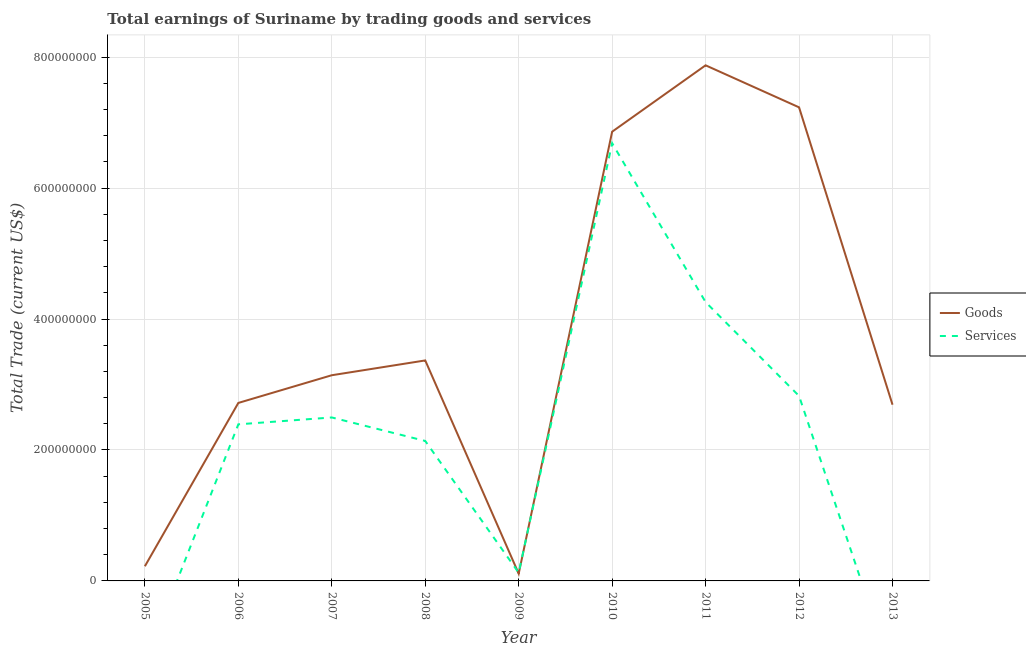How many different coloured lines are there?
Ensure brevity in your answer.  2. What is the amount earned by trading goods in 2007?
Ensure brevity in your answer.  3.14e+08. Across all years, what is the maximum amount earned by trading services?
Make the answer very short. 6.69e+08. In which year was the amount earned by trading services maximum?
Give a very brief answer. 2010. What is the total amount earned by trading services in the graph?
Make the answer very short. 2.09e+09. What is the difference between the amount earned by trading services in 2009 and that in 2011?
Make the answer very short. -4.13e+08. What is the difference between the amount earned by trading services in 2007 and the amount earned by trading goods in 2011?
Offer a terse response. -5.38e+08. What is the average amount earned by trading goods per year?
Offer a very short reply. 3.80e+08. In the year 2007, what is the difference between the amount earned by trading services and amount earned by trading goods?
Offer a very short reply. -6.45e+07. What is the ratio of the amount earned by trading services in 2010 to that in 2011?
Keep it short and to the point. 1.57. Is the difference between the amount earned by trading services in 2006 and 2008 greater than the difference between the amount earned by trading goods in 2006 and 2008?
Give a very brief answer. Yes. What is the difference between the highest and the second highest amount earned by trading services?
Your response must be concise. 2.43e+08. What is the difference between the highest and the lowest amount earned by trading goods?
Provide a succinct answer. 7.77e+08. Is the sum of the amount earned by trading goods in 2007 and 2010 greater than the maximum amount earned by trading services across all years?
Ensure brevity in your answer.  Yes. How many lines are there?
Keep it short and to the point. 2. Does the graph contain any zero values?
Ensure brevity in your answer.  Yes. How many legend labels are there?
Your response must be concise. 2. How are the legend labels stacked?
Offer a terse response. Vertical. What is the title of the graph?
Your response must be concise. Total earnings of Suriname by trading goods and services. Does "IMF concessional" appear as one of the legend labels in the graph?
Give a very brief answer. No. What is the label or title of the X-axis?
Your response must be concise. Year. What is the label or title of the Y-axis?
Provide a succinct answer. Total Trade (current US$). What is the Total Trade (current US$) in Goods in 2005?
Make the answer very short. 2.24e+07. What is the Total Trade (current US$) of Goods in 2006?
Give a very brief answer. 2.72e+08. What is the Total Trade (current US$) in Services in 2006?
Offer a terse response. 2.39e+08. What is the Total Trade (current US$) in Goods in 2007?
Provide a short and direct response. 3.14e+08. What is the Total Trade (current US$) of Services in 2007?
Make the answer very short. 2.50e+08. What is the Total Trade (current US$) in Goods in 2008?
Keep it short and to the point. 3.37e+08. What is the Total Trade (current US$) in Services in 2008?
Ensure brevity in your answer.  2.14e+08. What is the Total Trade (current US$) of Goods in 2009?
Offer a very short reply. 1.11e+07. What is the Total Trade (current US$) in Services in 2009?
Offer a terse response. 1.25e+07. What is the Total Trade (current US$) of Goods in 2010?
Provide a short and direct response. 6.86e+08. What is the Total Trade (current US$) in Services in 2010?
Provide a succinct answer. 6.69e+08. What is the Total Trade (current US$) in Goods in 2011?
Your answer should be compact. 7.88e+08. What is the Total Trade (current US$) in Services in 2011?
Ensure brevity in your answer.  4.26e+08. What is the Total Trade (current US$) of Goods in 2012?
Give a very brief answer. 7.23e+08. What is the Total Trade (current US$) in Services in 2012?
Offer a terse response. 2.83e+08. What is the Total Trade (current US$) in Goods in 2013?
Your answer should be compact. 2.69e+08. Across all years, what is the maximum Total Trade (current US$) in Goods?
Ensure brevity in your answer.  7.88e+08. Across all years, what is the maximum Total Trade (current US$) of Services?
Provide a succinct answer. 6.69e+08. Across all years, what is the minimum Total Trade (current US$) of Goods?
Provide a short and direct response. 1.11e+07. What is the total Total Trade (current US$) in Goods in the graph?
Your answer should be very brief. 3.42e+09. What is the total Total Trade (current US$) of Services in the graph?
Offer a very short reply. 2.09e+09. What is the difference between the Total Trade (current US$) of Goods in 2005 and that in 2006?
Your answer should be very brief. -2.50e+08. What is the difference between the Total Trade (current US$) in Goods in 2005 and that in 2007?
Offer a very short reply. -2.92e+08. What is the difference between the Total Trade (current US$) of Goods in 2005 and that in 2008?
Offer a terse response. -3.14e+08. What is the difference between the Total Trade (current US$) in Goods in 2005 and that in 2009?
Your answer should be compact. 1.13e+07. What is the difference between the Total Trade (current US$) in Goods in 2005 and that in 2010?
Provide a succinct answer. -6.64e+08. What is the difference between the Total Trade (current US$) of Goods in 2005 and that in 2011?
Provide a succinct answer. -7.65e+08. What is the difference between the Total Trade (current US$) of Goods in 2005 and that in 2012?
Your answer should be compact. -7.01e+08. What is the difference between the Total Trade (current US$) of Goods in 2005 and that in 2013?
Ensure brevity in your answer.  -2.47e+08. What is the difference between the Total Trade (current US$) in Goods in 2006 and that in 2007?
Make the answer very short. -4.23e+07. What is the difference between the Total Trade (current US$) in Services in 2006 and that in 2007?
Your answer should be compact. -1.05e+07. What is the difference between the Total Trade (current US$) in Goods in 2006 and that in 2008?
Offer a very short reply. -6.49e+07. What is the difference between the Total Trade (current US$) in Services in 2006 and that in 2008?
Ensure brevity in your answer.  2.54e+07. What is the difference between the Total Trade (current US$) in Goods in 2006 and that in 2009?
Your response must be concise. 2.61e+08. What is the difference between the Total Trade (current US$) in Services in 2006 and that in 2009?
Give a very brief answer. 2.27e+08. What is the difference between the Total Trade (current US$) of Goods in 2006 and that in 2010?
Make the answer very short. -4.14e+08. What is the difference between the Total Trade (current US$) of Services in 2006 and that in 2010?
Ensure brevity in your answer.  -4.29e+08. What is the difference between the Total Trade (current US$) in Goods in 2006 and that in 2011?
Provide a short and direct response. -5.16e+08. What is the difference between the Total Trade (current US$) in Services in 2006 and that in 2011?
Offer a very short reply. -1.87e+08. What is the difference between the Total Trade (current US$) of Goods in 2006 and that in 2012?
Provide a succinct answer. -4.52e+08. What is the difference between the Total Trade (current US$) of Services in 2006 and that in 2012?
Provide a short and direct response. -4.34e+07. What is the difference between the Total Trade (current US$) of Goods in 2006 and that in 2013?
Ensure brevity in your answer.  2.72e+06. What is the difference between the Total Trade (current US$) in Goods in 2007 and that in 2008?
Offer a terse response. -2.26e+07. What is the difference between the Total Trade (current US$) of Services in 2007 and that in 2008?
Keep it short and to the point. 3.59e+07. What is the difference between the Total Trade (current US$) in Goods in 2007 and that in 2009?
Offer a very short reply. 3.03e+08. What is the difference between the Total Trade (current US$) in Services in 2007 and that in 2009?
Your answer should be compact. 2.37e+08. What is the difference between the Total Trade (current US$) in Goods in 2007 and that in 2010?
Offer a very short reply. -3.72e+08. What is the difference between the Total Trade (current US$) of Services in 2007 and that in 2010?
Make the answer very short. -4.19e+08. What is the difference between the Total Trade (current US$) in Goods in 2007 and that in 2011?
Your answer should be very brief. -4.73e+08. What is the difference between the Total Trade (current US$) of Services in 2007 and that in 2011?
Keep it short and to the point. -1.76e+08. What is the difference between the Total Trade (current US$) of Goods in 2007 and that in 2012?
Keep it short and to the point. -4.09e+08. What is the difference between the Total Trade (current US$) of Services in 2007 and that in 2012?
Give a very brief answer. -3.29e+07. What is the difference between the Total Trade (current US$) in Goods in 2007 and that in 2013?
Provide a succinct answer. 4.50e+07. What is the difference between the Total Trade (current US$) of Goods in 2008 and that in 2009?
Your answer should be very brief. 3.26e+08. What is the difference between the Total Trade (current US$) of Services in 2008 and that in 2009?
Provide a short and direct response. 2.01e+08. What is the difference between the Total Trade (current US$) in Goods in 2008 and that in 2010?
Your response must be concise. -3.49e+08. What is the difference between the Total Trade (current US$) of Services in 2008 and that in 2010?
Offer a terse response. -4.55e+08. What is the difference between the Total Trade (current US$) in Goods in 2008 and that in 2011?
Give a very brief answer. -4.51e+08. What is the difference between the Total Trade (current US$) of Services in 2008 and that in 2011?
Offer a terse response. -2.12e+08. What is the difference between the Total Trade (current US$) of Goods in 2008 and that in 2012?
Offer a very short reply. -3.87e+08. What is the difference between the Total Trade (current US$) in Services in 2008 and that in 2012?
Ensure brevity in your answer.  -6.88e+07. What is the difference between the Total Trade (current US$) in Goods in 2008 and that in 2013?
Give a very brief answer. 6.76e+07. What is the difference between the Total Trade (current US$) in Goods in 2009 and that in 2010?
Provide a succinct answer. -6.75e+08. What is the difference between the Total Trade (current US$) in Services in 2009 and that in 2010?
Provide a short and direct response. -6.56e+08. What is the difference between the Total Trade (current US$) in Goods in 2009 and that in 2011?
Keep it short and to the point. -7.77e+08. What is the difference between the Total Trade (current US$) in Services in 2009 and that in 2011?
Your answer should be very brief. -4.13e+08. What is the difference between the Total Trade (current US$) of Goods in 2009 and that in 2012?
Ensure brevity in your answer.  -7.12e+08. What is the difference between the Total Trade (current US$) in Services in 2009 and that in 2012?
Ensure brevity in your answer.  -2.70e+08. What is the difference between the Total Trade (current US$) in Goods in 2009 and that in 2013?
Offer a very short reply. -2.58e+08. What is the difference between the Total Trade (current US$) of Goods in 2010 and that in 2011?
Your answer should be very brief. -1.01e+08. What is the difference between the Total Trade (current US$) of Services in 2010 and that in 2011?
Your answer should be very brief. 2.43e+08. What is the difference between the Total Trade (current US$) of Goods in 2010 and that in 2012?
Provide a succinct answer. -3.72e+07. What is the difference between the Total Trade (current US$) of Services in 2010 and that in 2012?
Give a very brief answer. 3.86e+08. What is the difference between the Total Trade (current US$) in Goods in 2010 and that in 2013?
Make the answer very short. 4.17e+08. What is the difference between the Total Trade (current US$) of Goods in 2011 and that in 2012?
Provide a short and direct response. 6.42e+07. What is the difference between the Total Trade (current US$) in Services in 2011 and that in 2012?
Offer a very short reply. 1.43e+08. What is the difference between the Total Trade (current US$) of Goods in 2011 and that in 2013?
Your answer should be very brief. 5.18e+08. What is the difference between the Total Trade (current US$) of Goods in 2012 and that in 2013?
Give a very brief answer. 4.54e+08. What is the difference between the Total Trade (current US$) of Goods in 2005 and the Total Trade (current US$) of Services in 2006?
Your answer should be very brief. -2.17e+08. What is the difference between the Total Trade (current US$) of Goods in 2005 and the Total Trade (current US$) of Services in 2007?
Make the answer very short. -2.27e+08. What is the difference between the Total Trade (current US$) in Goods in 2005 and the Total Trade (current US$) in Services in 2008?
Your answer should be very brief. -1.91e+08. What is the difference between the Total Trade (current US$) in Goods in 2005 and the Total Trade (current US$) in Services in 2009?
Give a very brief answer. 9.90e+06. What is the difference between the Total Trade (current US$) of Goods in 2005 and the Total Trade (current US$) of Services in 2010?
Ensure brevity in your answer.  -6.46e+08. What is the difference between the Total Trade (current US$) in Goods in 2005 and the Total Trade (current US$) in Services in 2011?
Make the answer very short. -4.04e+08. What is the difference between the Total Trade (current US$) of Goods in 2005 and the Total Trade (current US$) of Services in 2012?
Offer a very short reply. -2.60e+08. What is the difference between the Total Trade (current US$) of Goods in 2006 and the Total Trade (current US$) of Services in 2007?
Provide a short and direct response. 2.22e+07. What is the difference between the Total Trade (current US$) in Goods in 2006 and the Total Trade (current US$) in Services in 2008?
Offer a very short reply. 5.81e+07. What is the difference between the Total Trade (current US$) in Goods in 2006 and the Total Trade (current US$) in Services in 2009?
Offer a very short reply. 2.59e+08. What is the difference between the Total Trade (current US$) of Goods in 2006 and the Total Trade (current US$) of Services in 2010?
Give a very brief answer. -3.97e+08. What is the difference between the Total Trade (current US$) of Goods in 2006 and the Total Trade (current US$) of Services in 2011?
Your answer should be compact. -1.54e+08. What is the difference between the Total Trade (current US$) of Goods in 2006 and the Total Trade (current US$) of Services in 2012?
Make the answer very short. -1.07e+07. What is the difference between the Total Trade (current US$) of Goods in 2007 and the Total Trade (current US$) of Services in 2008?
Offer a very short reply. 1.00e+08. What is the difference between the Total Trade (current US$) in Goods in 2007 and the Total Trade (current US$) in Services in 2009?
Your answer should be very brief. 3.02e+08. What is the difference between the Total Trade (current US$) of Goods in 2007 and the Total Trade (current US$) of Services in 2010?
Offer a very short reply. -3.54e+08. What is the difference between the Total Trade (current US$) in Goods in 2007 and the Total Trade (current US$) in Services in 2011?
Keep it short and to the point. -1.12e+08. What is the difference between the Total Trade (current US$) in Goods in 2007 and the Total Trade (current US$) in Services in 2012?
Provide a short and direct response. 3.16e+07. What is the difference between the Total Trade (current US$) in Goods in 2008 and the Total Trade (current US$) in Services in 2009?
Offer a terse response. 3.24e+08. What is the difference between the Total Trade (current US$) of Goods in 2008 and the Total Trade (current US$) of Services in 2010?
Offer a terse response. -3.32e+08. What is the difference between the Total Trade (current US$) in Goods in 2008 and the Total Trade (current US$) in Services in 2011?
Keep it short and to the point. -8.91e+07. What is the difference between the Total Trade (current US$) of Goods in 2008 and the Total Trade (current US$) of Services in 2012?
Your response must be concise. 5.42e+07. What is the difference between the Total Trade (current US$) in Goods in 2009 and the Total Trade (current US$) in Services in 2010?
Your response must be concise. -6.58e+08. What is the difference between the Total Trade (current US$) of Goods in 2009 and the Total Trade (current US$) of Services in 2011?
Your response must be concise. -4.15e+08. What is the difference between the Total Trade (current US$) in Goods in 2009 and the Total Trade (current US$) in Services in 2012?
Offer a very short reply. -2.71e+08. What is the difference between the Total Trade (current US$) in Goods in 2010 and the Total Trade (current US$) in Services in 2011?
Provide a short and direct response. 2.60e+08. What is the difference between the Total Trade (current US$) in Goods in 2010 and the Total Trade (current US$) in Services in 2012?
Your answer should be compact. 4.04e+08. What is the difference between the Total Trade (current US$) of Goods in 2011 and the Total Trade (current US$) of Services in 2012?
Provide a short and direct response. 5.05e+08. What is the average Total Trade (current US$) in Goods per year?
Provide a succinct answer. 3.80e+08. What is the average Total Trade (current US$) of Services per year?
Ensure brevity in your answer.  2.32e+08. In the year 2006, what is the difference between the Total Trade (current US$) in Goods and Total Trade (current US$) in Services?
Provide a short and direct response. 3.27e+07. In the year 2007, what is the difference between the Total Trade (current US$) in Goods and Total Trade (current US$) in Services?
Give a very brief answer. 6.45e+07. In the year 2008, what is the difference between the Total Trade (current US$) of Goods and Total Trade (current US$) of Services?
Your response must be concise. 1.23e+08. In the year 2009, what is the difference between the Total Trade (current US$) of Goods and Total Trade (current US$) of Services?
Your answer should be very brief. -1.40e+06. In the year 2010, what is the difference between the Total Trade (current US$) in Goods and Total Trade (current US$) in Services?
Provide a succinct answer. 1.76e+07. In the year 2011, what is the difference between the Total Trade (current US$) in Goods and Total Trade (current US$) in Services?
Ensure brevity in your answer.  3.62e+08. In the year 2012, what is the difference between the Total Trade (current US$) of Goods and Total Trade (current US$) of Services?
Your answer should be very brief. 4.41e+08. What is the ratio of the Total Trade (current US$) in Goods in 2005 to that in 2006?
Give a very brief answer. 0.08. What is the ratio of the Total Trade (current US$) of Goods in 2005 to that in 2007?
Your answer should be compact. 0.07. What is the ratio of the Total Trade (current US$) of Goods in 2005 to that in 2008?
Your answer should be very brief. 0.07. What is the ratio of the Total Trade (current US$) in Goods in 2005 to that in 2009?
Your answer should be very brief. 2.02. What is the ratio of the Total Trade (current US$) of Goods in 2005 to that in 2010?
Keep it short and to the point. 0.03. What is the ratio of the Total Trade (current US$) in Goods in 2005 to that in 2011?
Your answer should be very brief. 0.03. What is the ratio of the Total Trade (current US$) of Goods in 2005 to that in 2012?
Ensure brevity in your answer.  0.03. What is the ratio of the Total Trade (current US$) in Goods in 2005 to that in 2013?
Ensure brevity in your answer.  0.08. What is the ratio of the Total Trade (current US$) in Goods in 2006 to that in 2007?
Ensure brevity in your answer.  0.87. What is the ratio of the Total Trade (current US$) in Services in 2006 to that in 2007?
Provide a short and direct response. 0.96. What is the ratio of the Total Trade (current US$) of Goods in 2006 to that in 2008?
Ensure brevity in your answer.  0.81. What is the ratio of the Total Trade (current US$) in Services in 2006 to that in 2008?
Provide a short and direct response. 1.12. What is the ratio of the Total Trade (current US$) of Goods in 2006 to that in 2009?
Offer a very short reply. 24.5. What is the ratio of the Total Trade (current US$) of Services in 2006 to that in 2009?
Provide a short and direct response. 19.14. What is the ratio of the Total Trade (current US$) of Goods in 2006 to that in 2010?
Offer a terse response. 0.4. What is the ratio of the Total Trade (current US$) in Services in 2006 to that in 2010?
Your answer should be very brief. 0.36. What is the ratio of the Total Trade (current US$) in Goods in 2006 to that in 2011?
Provide a short and direct response. 0.35. What is the ratio of the Total Trade (current US$) of Services in 2006 to that in 2011?
Offer a very short reply. 0.56. What is the ratio of the Total Trade (current US$) in Goods in 2006 to that in 2012?
Your answer should be very brief. 0.38. What is the ratio of the Total Trade (current US$) in Services in 2006 to that in 2012?
Your answer should be very brief. 0.85. What is the ratio of the Total Trade (current US$) in Goods in 2007 to that in 2008?
Give a very brief answer. 0.93. What is the ratio of the Total Trade (current US$) in Services in 2007 to that in 2008?
Offer a very short reply. 1.17. What is the ratio of the Total Trade (current US$) of Goods in 2007 to that in 2009?
Provide a short and direct response. 28.31. What is the ratio of the Total Trade (current US$) in Services in 2007 to that in 2009?
Your answer should be compact. 19.98. What is the ratio of the Total Trade (current US$) in Goods in 2007 to that in 2010?
Keep it short and to the point. 0.46. What is the ratio of the Total Trade (current US$) of Services in 2007 to that in 2010?
Ensure brevity in your answer.  0.37. What is the ratio of the Total Trade (current US$) of Goods in 2007 to that in 2011?
Provide a succinct answer. 0.4. What is the ratio of the Total Trade (current US$) in Services in 2007 to that in 2011?
Offer a terse response. 0.59. What is the ratio of the Total Trade (current US$) in Goods in 2007 to that in 2012?
Make the answer very short. 0.43. What is the ratio of the Total Trade (current US$) in Services in 2007 to that in 2012?
Your response must be concise. 0.88. What is the ratio of the Total Trade (current US$) in Goods in 2007 to that in 2013?
Your answer should be compact. 1.17. What is the ratio of the Total Trade (current US$) in Goods in 2008 to that in 2009?
Your response must be concise. 30.34. What is the ratio of the Total Trade (current US$) of Services in 2008 to that in 2009?
Offer a very short reply. 17.1. What is the ratio of the Total Trade (current US$) of Goods in 2008 to that in 2010?
Provide a succinct answer. 0.49. What is the ratio of the Total Trade (current US$) of Services in 2008 to that in 2010?
Your answer should be compact. 0.32. What is the ratio of the Total Trade (current US$) of Goods in 2008 to that in 2011?
Offer a very short reply. 0.43. What is the ratio of the Total Trade (current US$) in Services in 2008 to that in 2011?
Give a very brief answer. 0.5. What is the ratio of the Total Trade (current US$) in Goods in 2008 to that in 2012?
Offer a terse response. 0.47. What is the ratio of the Total Trade (current US$) in Services in 2008 to that in 2012?
Offer a very short reply. 0.76. What is the ratio of the Total Trade (current US$) in Goods in 2008 to that in 2013?
Your response must be concise. 1.25. What is the ratio of the Total Trade (current US$) in Goods in 2009 to that in 2010?
Ensure brevity in your answer.  0.02. What is the ratio of the Total Trade (current US$) of Services in 2009 to that in 2010?
Give a very brief answer. 0.02. What is the ratio of the Total Trade (current US$) of Goods in 2009 to that in 2011?
Your answer should be very brief. 0.01. What is the ratio of the Total Trade (current US$) in Services in 2009 to that in 2011?
Offer a terse response. 0.03. What is the ratio of the Total Trade (current US$) in Goods in 2009 to that in 2012?
Offer a terse response. 0.02. What is the ratio of the Total Trade (current US$) of Services in 2009 to that in 2012?
Make the answer very short. 0.04. What is the ratio of the Total Trade (current US$) of Goods in 2009 to that in 2013?
Make the answer very short. 0.04. What is the ratio of the Total Trade (current US$) of Goods in 2010 to that in 2011?
Give a very brief answer. 0.87. What is the ratio of the Total Trade (current US$) of Services in 2010 to that in 2011?
Make the answer very short. 1.57. What is the ratio of the Total Trade (current US$) in Goods in 2010 to that in 2012?
Keep it short and to the point. 0.95. What is the ratio of the Total Trade (current US$) in Services in 2010 to that in 2012?
Keep it short and to the point. 2.37. What is the ratio of the Total Trade (current US$) in Goods in 2010 to that in 2013?
Offer a terse response. 2.55. What is the ratio of the Total Trade (current US$) of Goods in 2011 to that in 2012?
Ensure brevity in your answer.  1.09. What is the ratio of the Total Trade (current US$) of Services in 2011 to that in 2012?
Keep it short and to the point. 1.51. What is the ratio of the Total Trade (current US$) in Goods in 2011 to that in 2013?
Offer a very short reply. 2.93. What is the ratio of the Total Trade (current US$) of Goods in 2012 to that in 2013?
Your response must be concise. 2.69. What is the difference between the highest and the second highest Total Trade (current US$) of Goods?
Your response must be concise. 6.42e+07. What is the difference between the highest and the second highest Total Trade (current US$) in Services?
Offer a very short reply. 2.43e+08. What is the difference between the highest and the lowest Total Trade (current US$) of Goods?
Make the answer very short. 7.77e+08. What is the difference between the highest and the lowest Total Trade (current US$) in Services?
Offer a terse response. 6.69e+08. 